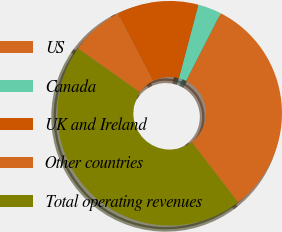<chart> <loc_0><loc_0><loc_500><loc_500><pie_chart><fcel>US<fcel>Canada<fcel>UK and Ireland<fcel>Other countries<fcel>Total operating revenues<nl><fcel>32.06%<fcel>3.39%<fcel>11.76%<fcel>7.57%<fcel>45.23%<nl></chart> 